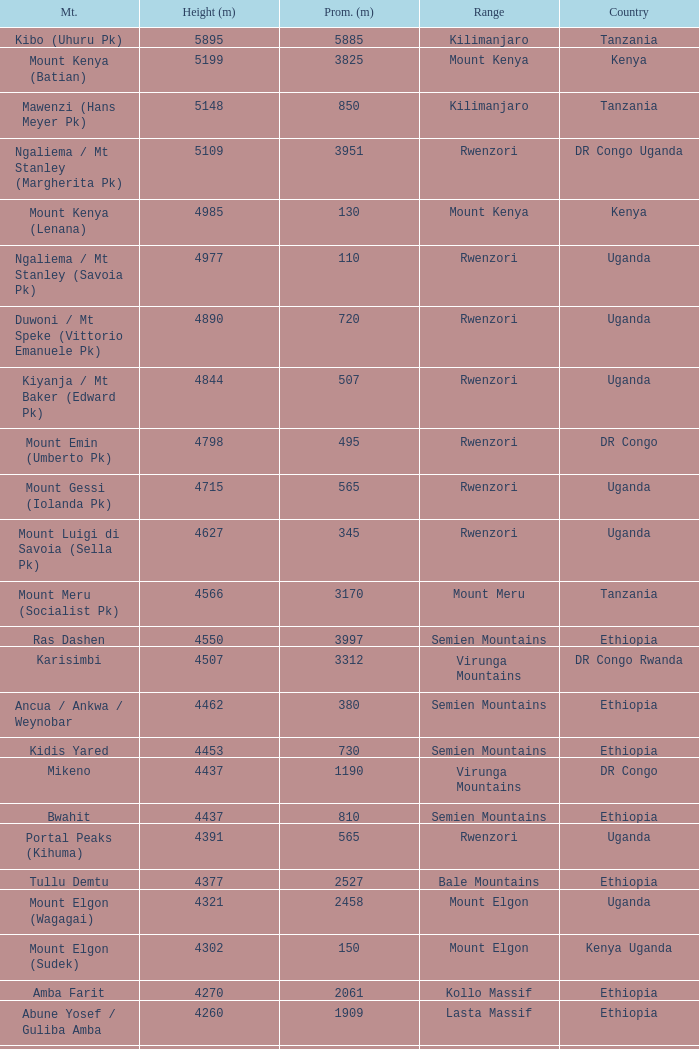How tall is the Mountain of jbel ghat? 1.0. 